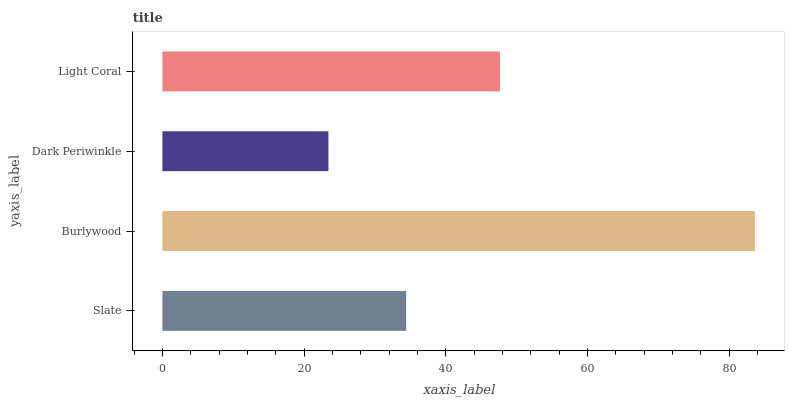Is Dark Periwinkle the minimum?
Answer yes or no. Yes. Is Burlywood the maximum?
Answer yes or no. Yes. Is Burlywood the minimum?
Answer yes or no. No. Is Dark Periwinkle the maximum?
Answer yes or no. No. Is Burlywood greater than Dark Periwinkle?
Answer yes or no. Yes. Is Dark Periwinkle less than Burlywood?
Answer yes or no. Yes. Is Dark Periwinkle greater than Burlywood?
Answer yes or no. No. Is Burlywood less than Dark Periwinkle?
Answer yes or no. No. Is Light Coral the high median?
Answer yes or no. Yes. Is Slate the low median?
Answer yes or no. Yes. Is Slate the high median?
Answer yes or no. No. Is Dark Periwinkle the low median?
Answer yes or no. No. 